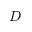Convert formula to latex. <formula><loc_0><loc_0><loc_500><loc_500>D</formula> 